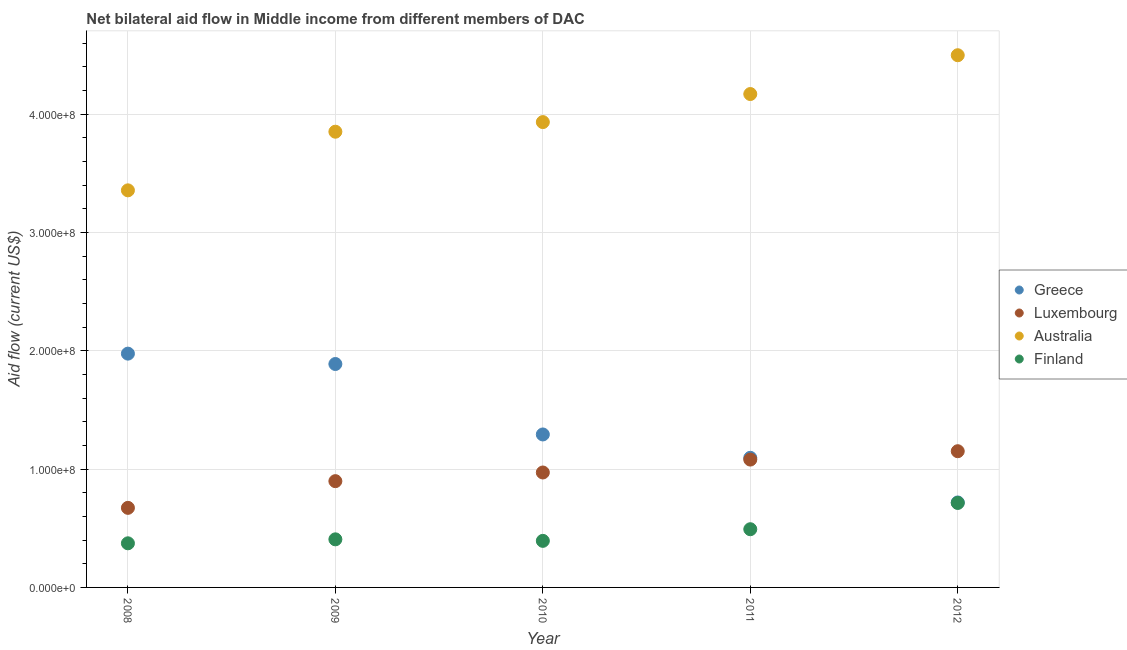What is the amount of aid given by greece in 2010?
Your response must be concise. 1.29e+08. Across all years, what is the maximum amount of aid given by luxembourg?
Your response must be concise. 1.15e+08. Across all years, what is the minimum amount of aid given by australia?
Provide a succinct answer. 3.36e+08. What is the total amount of aid given by australia in the graph?
Your answer should be compact. 1.98e+09. What is the difference between the amount of aid given by australia in 2008 and that in 2009?
Give a very brief answer. -4.96e+07. What is the difference between the amount of aid given by greece in 2012 and the amount of aid given by luxembourg in 2009?
Keep it short and to the point. -1.80e+07. What is the average amount of aid given by australia per year?
Provide a short and direct response. 3.96e+08. In the year 2012, what is the difference between the amount of aid given by luxembourg and amount of aid given by greece?
Provide a short and direct response. 4.33e+07. What is the ratio of the amount of aid given by australia in 2009 to that in 2011?
Ensure brevity in your answer.  0.92. What is the difference between the highest and the second highest amount of aid given by finland?
Your answer should be compact. 2.22e+07. What is the difference between the highest and the lowest amount of aid given by finland?
Keep it short and to the point. 3.41e+07. In how many years, is the amount of aid given by luxembourg greater than the average amount of aid given by luxembourg taken over all years?
Provide a succinct answer. 3. Is the amount of aid given by greece strictly greater than the amount of aid given by australia over the years?
Ensure brevity in your answer.  No. Is the amount of aid given by greece strictly less than the amount of aid given by luxembourg over the years?
Offer a very short reply. No. How many years are there in the graph?
Offer a terse response. 5. How many legend labels are there?
Keep it short and to the point. 4. What is the title of the graph?
Your answer should be compact. Net bilateral aid flow in Middle income from different members of DAC. What is the Aid flow (current US$) in Greece in 2008?
Provide a short and direct response. 1.98e+08. What is the Aid flow (current US$) in Luxembourg in 2008?
Offer a very short reply. 6.73e+07. What is the Aid flow (current US$) of Australia in 2008?
Keep it short and to the point. 3.36e+08. What is the Aid flow (current US$) of Finland in 2008?
Give a very brief answer. 3.73e+07. What is the Aid flow (current US$) of Greece in 2009?
Offer a terse response. 1.89e+08. What is the Aid flow (current US$) in Luxembourg in 2009?
Provide a short and direct response. 8.98e+07. What is the Aid flow (current US$) in Australia in 2009?
Your response must be concise. 3.85e+08. What is the Aid flow (current US$) of Finland in 2009?
Your answer should be compact. 4.06e+07. What is the Aid flow (current US$) of Greece in 2010?
Your answer should be very brief. 1.29e+08. What is the Aid flow (current US$) of Luxembourg in 2010?
Make the answer very short. 9.72e+07. What is the Aid flow (current US$) of Australia in 2010?
Your response must be concise. 3.93e+08. What is the Aid flow (current US$) in Finland in 2010?
Your answer should be very brief. 3.94e+07. What is the Aid flow (current US$) of Greece in 2011?
Provide a succinct answer. 1.10e+08. What is the Aid flow (current US$) in Luxembourg in 2011?
Provide a succinct answer. 1.08e+08. What is the Aid flow (current US$) in Australia in 2011?
Provide a short and direct response. 4.17e+08. What is the Aid flow (current US$) in Finland in 2011?
Provide a succinct answer. 4.92e+07. What is the Aid flow (current US$) of Greece in 2012?
Keep it short and to the point. 7.18e+07. What is the Aid flow (current US$) in Luxembourg in 2012?
Make the answer very short. 1.15e+08. What is the Aid flow (current US$) of Australia in 2012?
Your response must be concise. 4.50e+08. What is the Aid flow (current US$) in Finland in 2012?
Make the answer very short. 7.14e+07. Across all years, what is the maximum Aid flow (current US$) in Greece?
Your answer should be very brief. 1.98e+08. Across all years, what is the maximum Aid flow (current US$) of Luxembourg?
Keep it short and to the point. 1.15e+08. Across all years, what is the maximum Aid flow (current US$) in Australia?
Offer a terse response. 4.50e+08. Across all years, what is the maximum Aid flow (current US$) in Finland?
Provide a succinct answer. 7.14e+07. Across all years, what is the minimum Aid flow (current US$) in Greece?
Ensure brevity in your answer.  7.18e+07. Across all years, what is the minimum Aid flow (current US$) in Luxembourg?
Provide a succinct answer. 6.73e+07. Across all years, what is the minimum Aid flow (current US$) in Australia?
Make the answer very short. 3.36e+08. Across all years, what is the minimum Aid flow (current US$) of Finland?
Provide a short and direct response. 3.73e+07. What is the total Aid flow (current US$) of Greece in the graph?
Your answer should be compact. 6.97e+08. What is the total Aid flow (current US$) of Luxembourg in the graph?
Offer a very short reply. 4.77e+08. What is the total Aid flow (current US$) in Australia in the graph?
Offer a very short reply. 1.98e+09. What is the total Aid flow (current US$) of Finland in the graph?
Offer a very short reply. 2.38e+08. What is the difference between the Aid flow (current US$) of Greece in 2008 and that in 2009?
Offer a very short reply. 8.77e+06. What is the difference between the Aid flow (current US$) of Luxembourg in 2008 and that in 2009?
Provide a succinct answer. -2.26e+07. What is the difference between the Aid flow (current US$) of Australia in 2008 and that in 2009?
Keep it short and to the point. -4.96e+07. What is the difference between the Aid flow (current US$) in Finland in 2008 and that in 2009?
Your answer should be very brief. -3.36e+06. What is the difference between the Aid flow (current US$) in Greece in 2008 and that in 2010?
Ensure brevity in your answer.  6.83e+07. What is the difference between the Aid flow (current US$) of Luxembourg in 2008 and that in 2010?
Ensure brevity in your answer.  -2.99e+07. What is the difference between the Aid flow (current US$) in Australia in 2008 and that in 2010?
Ensure brevity in your answer.  -5.77e+07. What is the difference between the Aid flow (current US$) in Finland in 2008 and that in 2010?
Offer a very short reply. -2.07e+06. What is the difference between the Aid flow (current US$) of Greece in 2008 and that in 2011?
Offer a terse response. 8.81e+07. What is the difference between the Aid flow (current US$) of Luxembourg in 2008 and that in 2011?
Give a very brief answer. -4.08e+07. What is the difference between the Aid flow (current US$) in Australia in 2008 and that in 2011?
Offer a terse response. -8.14e+07. What is the difference between the Aid flow (current US$) of Finland in 2008 and that in 2011?
Provide a short and direct response. -1.19e+07. What is the difference between the Aid flow (current US$) in Greece in 2008 and that in 2012?
Ensure brevity in your answer.  1.26e+08. What is the difference between the Aid flow (current US$) in Luxembourg in 2008 and that in 2012?
Your response must be concise. -4.79e+07. What is the difference between the Aid flow (current US$) in Australia in 2008 and that in 2012?
Offer a terse response. -1.14e+08. What is the difference between the Aid flow (current US$) of Finland in 2008 and that in 2012?
Offer a very short reply. -3.41e+07. What is the difference between the Aid flow (current US$) of Greece in 2009 and that in 2010?
Provide a short and direct response. 5.96e+07. What is the difference between the Aid flow (current US$) in Luxembourg in 2009 and that in 2010?
Provide a succinct answer. -7.32e+06. What is the difference between the Aid flow (current US$) of Australia in 2009 and that in 2010?
Provide a succinct answer. -8.13e+06. What is the difference between the Aid flow (current US$) in Finland in 2009 and that in 2010?
Your answer should be compact. 1.29e+06. What is the difference between the Aid flow (current US$) in Greece in 2009 and that in 2011?
Your answer should be very brief. 7.93e+07. What is the difference between the Aid flow (current US$) of Luxembourg in 2009 and that in 2011?
Ensure brevity in your answer.  -1.82e+07. What is the difference between the Aid flow (current US$) of Australia in 2009 and that in 2011?
Offer a very short reply. -3.18e+07. What is the difference between the Aid flow (current US$) of Finland in 2009 and that in 2011?
Give a very brief answer. -8.55e+06. What is the difference between the Aid flow (current US$) of Greece in 2009 and that in 2012?
Offer a terse response. 1.17e+08. What is the difference between the Aid flow (current US$) in Luxembourg in 2009 and that in 2012?
Your answer should be compact. -2.53e+07. What is the difference between the Aid flow (current US$) in Australia in 2009 and that in 2012?
Your answer should be compact. -6.46e+07. What is the difference between the Aid flow (current US$) of Finland in 2009 and that in 2012?
Ensure brevity in your answer.  -3.08e+07. What is the difference between the Aid flow (current US$) in Greece in 2010 and that in 2011?
Offer a terse response. 1.98e+07. What is the difference between the Aid flow (current US$) of Luxembourg in 2010 and that in 2011?
Your answer should be compact. -1.09e+07. What is the difference between the Aid flow (current US$) of Australia in 2010 and that in 2011?
Offer a very short reply. -2.37e+07. What is the difference between the Aid flow (current US$) in Finland in 2010 and that in 2011?
Make the answer very short. -9.84e+06. What is the difference between the Aid flow (current US$) in Greece in 2010 and that in 2012?
Provide a short and direct response. 5.75e+07. What is the difference between the Aid flow (current US$) in Luxembourg in 2010 and that in 2012?
Make the answer very short. -1.80e+07. What is the difference between the Aid flow (current US$) of Australia in 2010 and that in 2012?
Your response must be concise. -5.65e+07. What is the difference between the Aid flow (current US$) of Finland in 2010 and that in 2012?
Offer a very short reply. -3.20e+07. What is the difference between the Aid flow (current US$) in Greece in 2011 and that in 2012?
Your answer should be compact. 3.77e+07. What is the difference between the Aid flow (current US$) in Luxembourg in 2011 and that in 2012?
Keep it short and to the point. -7.07e+06. What is the difference between the Aid flow (current US$) in Australia in 2011 and that in 2012?
Give a very brief answer. -3.28e+07. What is the difference between the Aid flow (current US$) in Finland in 2011 and that in 2012?
Give a very brief answer. -2.22e+07. What is the difference between the Aid flow (current US$) in Greece in 2008 and the Aid flow (current US$) in Luxembourg in 2009?
Ensure brevity in your answer.  1.08e+08. What is the difference between the Aid flow (current US$) in Greece in 2008 and the Aid flow (current US$) in Australia in 2009?
Provide a short and direct response. -1.88e+08. What is the difference between the Aid flow (current US$) in Greece in 2008 and the Aid flow (current US$) in Finland in 2009?
Provide a short and direct response. 1.57e+08. What is the difference between the Aid flow (current US$) of Luxembourg in 2008 and the Aid flow (current US$) of Australia in 2009?
Offer a very short reply. -3.18e+08. What is the difference between the Aid flow (current US$) in Luxembourg in 2008 and the Aid flow (current US$) in Finland in 2009?
Your response must be concise. 2.66e+07. What is the difference between the Aid flow (current US$) in Australia in 2008 and the Aid flow (current US$) in Finland in 2009?
Provide a short and direct response. 2.95e+08. What is the difference between the Aid flow (current US$) in Greece in 2008 and the Aid flow (current US$) in Luxembourg in 2010?
Provide a succinct answer. 1.00e+08. What is the difference between the Aid flow (current US$) of Greece in 2008 and the Aid flow (current US$) of Australia in 2010?
Offer a terse response. -1.96e+08. What is the difference between the Aid flow (current US$) in Greece in 2008 and the Aid flow (current US$) in Finland in 2010?
Offer a terse response. 1.58e+08. What is the difference between the Aid flow (current US$) of Luxembourg in 2008 and the Aid flow (current US$) of Australia in 2010?
Offer a very short reply. -3.26e+08. What is the difference between the Aid flow (current US$) in Luxembourg in 2008 and the Aid flow (current US$) in Finland in 2010?
Ensure brevity in your answer.  2.79e+07. What is the difference between the Aid flow (current US$) of Australia in 2008 and the Aid flow (current US$) of Finland in 2010?
Ensure brevity in your answer.  2.96e+08. What is the difference between the Aid flow (current US$) of Greece in 2008 and the Aid flow (current US$) of Luxembourg in 2011?
Make the answer very short. 8.96e+07. What is the difference between the Aid flow (current US$) in Greece in 2008 and the Aid flow (current US$) in Australia in 2011?
Offer a terse response. -2.19e+08. What is the difference between the Aid flow (current US$) of Greece in 2008 and the Aid flow (current US$) of Finland in 2011?
Keep it short and to the point. 1.48e+08. What is the difference between the Aid flow (current US$) of Luxembourg in 2008 and the Aid flow (current US$) of Australia in 2011?
Offer a very short reply. -3.50e+08. What is the difference between the Aid flow (current US$) in Luxembourg in 2008 and the Aid flow (current US$) in Finland in 2011?
Keep it short and to the point. 1.81e+07. What is the difference between the Aid flow (current US$) of Australia in 2008 and the Aid flow (current US$) of Finland in 2011?
Make the answer very short. 2.86e+08. What is the difference between the Aid flow (current US$) of Greece in 2008 and the Aid flow (current US$) of Luxembourg in 2012?
Provide a short and direct response. 8.25e+07. What is the difference between the Aid flow (current US$) of Greece in 2008 and the Aid flow (current US$) of Australia in 2012?
Provide a short and direct response. -2.52e+08. What is the difference between the Aid flow (current US$) in Greece in 2008 and the Aid flow (current US$) in Finland in 2012?
Make the answer very short. 1.26e+08. What is the difference between the Aid flow (current US$) in Luxembourg in 2008 and the Aid flow (current US$) in Australia in 2012?
Your response must be concise. -3.83e+08. What is the difference between the Aid flow (current US$) in Luxembourg in 2008 and the Aid flow (current US$) in Finland in 2012?
Offer a terse response. -4.15e+06. What is the difference between the Aid flow (current US$) of Australia in 2008 and the Aid flow (current US$) of Finland in 2012?
Give a very brief answer. 2.64e+08. What is the difference between the Aid flow (current US$) of Greece in 2009 and the Aid flow (current US$) of Luxembourg in 2010?
Offer a terse response. 9.17e+07. What is the difference between the Aid flow (current US$) of Greece in 2009 and the Aid flow (current US$) of Australia in 2010?
Your answer should be very brief. -2.04e+08. What is the difference between the Aid flow (current US$) in Greece in 2009 and the Aid flow (current US$) in Finland in 2010?
Your answer should be very brief. 1.49e+08. What is the difference between the Aid flow (current US$) in Luxembourg in 2009 and the Aid flow (current US$) in Australia in 2010?
Your answer should be very brief. -3.04e+08. What is the difference between the Aid flow (current US$) of Luxembourg in 2009 and the Aid flow (current US$) of Finland in 2010?
Offer a terse response. 5.05e+07. What is the difference between the Aid flow (current US$) in Australia in 2009 and the Aid flow (current US$) in Finland in 2010?
Your response must be concise. 3.46e+08. What is the difference between the Aid flow (current US$) of Greece in 2009 and the Aid flow (current US$) of Luxembourg in 2011?
Provide a succinct answer. 8.08e+07. What is the difference between the Aid flow (current US$) of Greece in 2009 and the Aid flow (current US$) of Australia in 2011?
Ensure brevity in your answer.  -2.28e+08. What is the difference between the Aid flow (current US$) in Greece in 2009 and the Aid flow (current US$) in Finland in 2011?
Ensure brevity in your answer.  1.40e+08. What is the difference between the Aid flow (current US$) in Luxembourg in 2009 and the Aid flow (current US$) in Australia in 2011?
Offer a very short reply. -3.27e+08. What is the difference between the Aid flow (current US$) of Luxembourg in 2009 and the Aid flow (current US$) of Finland in 2011?
Offer a terse response. 4.06e+07. What is the difference between the Aid flow (current US$) of Australia in 2009 and the Aid flow (current US$) of Finland in 2011?
Offer a terse response. 3.36e+08. What is the difference between the Aid flow (current US$) in Greece in 2009 and the Aid flow (current US$) in Luxembourg in 2012?
Your answer should be very brief. 7.37e+07. What is the difference between the Aid flow (current US$) of Greece in 2009 and the Aid flow (current US$) of Australia in 2012?
Ensure brevity in your answer.  -2.61e+08. What is the difference between the Aid flow (current US$) of Greece in 2009 and the Aid flow (current US$) of Finland in 2012?
Give a very brief answer. 1.17e+08. What is the difference between the Aid flow (current US$) in Luxembourg in 2009 and the Aid flow (current US$) in Australia in 2012?
Offer a very short reply. -3.60e+08. What is the difference between the Aid flow (current US$) in Luxembourg in 2009 and the Aid flow (current US$) in Finland in 2012?
Offer a terse response. 1.84e+07. What is the difference between the Aid flow (current US$) of Australia in 2009 and the Aid flow (current US$) of Finland in 2012?
Offer a terse response. 3.14e+08. What is the difference between the Aid flow (current US$) of Greece in 2010 and the Aid flow (current US$) of Luxembourg in 2011?
Offer a very short reply. 2.12e+07. What is the difference between the Aid flow (current US$) of Greece in 2010 and the Aid flow (current US$) of Australia in 2011?
Provide a short and direct response. -2.88e+08. What is the difference between the Aid flow (current US$) in Greece in 2010 and the Aid flow (current US$) in Finland in 2011?
Make the answer very short. 8.01e+07. What is the difference between the Aid flow (current US$) in Luxembourg in 2010 and the Aid flow (current US$) in Australia in 2011?
Offer a very short reply. -3.20e+08. What is the difference between the Aid flow (current US$) in Luxembourg in 2010 and the Aid flow (current US$) in Finland in 2011?
Offer a terse response. 4.80e+07. What is the difference between the Aid flow (current US$) of Australia in 2010 and the Aid flow (current US$) of Finland in 2011?
Your answer should be compact. 3.44e+08. What is the difference between the Aid flow (current US$) in Greece in 2010 and the Aid flow (current US$) in Luxembourg in 2012?
Your response must be concise. 1.42e+07. What is the difference between the Aid flow (current US$) of Greece in 2010 and the Aid flow (current US$) of Australia in 2012?
Offer a very short reply. -3.21e+08. What is the difference between the Aid flow (current US$) in Greece in 2010 and the Aid flow (current US$) in Finland in 2012?
Make the answer very short. 5.79e+07. What is the difference between the Aid flow (current US$) in Luxembourg in 2010 and the Aid flow (current US$) in Australia in 2012?
Offer a very short reply. -3.53e+08. What is the difference between the Aid flow (current US$) of Luxembourg in 2010 and the Aid flow (current US$) of Finland in 2012?
Your answer should be very brief. 2.57e+07. What is the difference between the Aid flow (current US$) in Australia in 2010 and the Aid flow (current US$) in Finland in 2012?
Keep it short and to the point. 3.22e+08. What is the difference between the Aid flow (current US$) of Greece in 2011 and the Aid flow (current US$) of Luxembourg in 2012?
Your answer should be very brief. -5.59e+06. What is the difference between the Aid flow (current US$) of Greece in 2011 and the Aid flow (current US$) of Australia in 2012?
Your answer should be very brief. -3.40e+08. What is the difference between the Aid flow (current US$) of Greece in 2011 and the Aid flow (current US$) of Finland in 2012?
Provide a succinct answer. 3.81e+07. What is the difference between the Aid flow (current US$) of Luxembourg in 2011 and the Aid flow (current US$) of Australia in 2012?
Your response must be concise. -3.42e+08. What is the difference between the Aid flow (current US$) of Luxembourg in 2011 and the Aid flow (current US$) of Finland in 2012?
Offer a very short reply. 3.67e+07. What is the difference between the Aid flow (current US$) in Australia in 2011 and the Aid flow (current US$) in Finland in 2012?
Make the answer very short. 3.46e+08. What is the average Aid flow (current US$) in Greece per year?
Provide a succinct answer. 1.39e+08. What is the average Aid flow (current US$) of Luxembourg per year?
Offer a terse response. 9.55e+07. What is the average Aid flow (current US$) of Australia per year?
Give a very brief answer. 3.96e+08. What is the average Aid flow (current US$) in Finland per year?
Provide a short and direct response. 4.76e+07. In the year 2008, what is the difference between the Aid flow (current US$) of Greece and Aid flow (current US$) of Luxembourg?
Offer a terse response. 1.30e+08. In the year 2008, what is the difference between the Aid flow (current US$) in Greece and Aid flow (current US$) in Australia?
Ensure brevity in your answer.  -1.38e+08. In the year 2008, what is the difference between the Aid flow (current US$) in Greece and Aid flow (current US$) in Finland?
Your answer should be compact. 1.60e+08. In the year 2008, what is the difference between the Aid flow (current US$) in Luxembourg and Aid flow (current US$) in Australia?
Keep it short and to the point. -2.68e+08. In the year 2008, what is the difference between the Aid flow (current US$) in Luxembourg and Aid flow (current US$) in Finland?
Offer a very short reply. 3.00e+07. In the year 2008, what is the difference between the Aid flow (current US$) of Australia and Aid flow (current US$) of Finland?
Give a very brief answer. 2.98e+08. In the year 2009, what is the difference between the Aid flow (current US$) of Greece and Aid flow (current US$) of Luxembourg?
Your answer should be compact. 9.90e+07. In the year 2009, what is the difference between the Aid flow (current US$) of Greece and Aid flow (current US$) of Australia?
Make the answer very short. -1.96e+08. In the year 2009, what is the difference between the Aid flow (current US$) in Greece and Aid flow (current US$) in Finland?
Your response must be concise. 1.48e+08. In the year 2009, what is the difference between the Aid flow (current US$) of Luxembourg and Aid flow (current US$) of Australia?
Provide a succinct answer. -2.95e+08. In the year 2009, what is the difference between the Aid flow (current US$) in Luxembourg and Aid flow (current US$) in Finland?
Keep it short and to the point. 4.92e+07. In the year 2009, what is the difference between the Aid flow (current US$) of Australia and Aid flow (current US$) of Finland?
Keep it short and to the point. 3.45e+08. In the year 2010, what is the difference between the Aid flow (current US$) in Greece and Aid flow (current US$) in Luxembourg?
Your answer should be very brief. 3.22e+07. In the year 2010, what is the difference between the Aid flow (current US$) in Greece and Aid flow (current US$) in Australia?
Offer a very short reply. -2.64e+08. In the year 2010, what is the difference between the Aid flow (current US$) in Greece and Aid flow (current US$) in Finland?
Ensure brevity in your answer.  8.99e+07. In the year 2010, what is the difference between the Aid flow (current US$) of Luxembourg and Aid flow (current US$) of Australia?
Make the answer very short. -2.96e+08. In the year 2010, what is the difference between the Aid flow (current US$) of Luxembourg and Aid flow (current US$) of Finland?
Your answer should be compact. 5.78e+07. In the year 2010, what is the difference between the Aid flow (current US$) in Australia and Aid flow (current US$) in Finland?
Make the answer very short. 3.54e+08. In the year 2011, what is the difference between the Aid flow (current US$) in Greece and Aid flow (current US$) in Luxembourg?
Offer a terse response. 1.48e+06. In the year 2011, what is the difference between the Aid flow (current US$) of Greece and Aid flow (current US$) of Australia?
Your response must be concise. -3.08e+08. In the year 2011, what is the difference between the Aid flow (current US$) in Greece and Aid flow (current US$) in Finland?
Give a very brief answer. 6.04e+07. In the year 2011, what is the difference between the Aid flow (current US$) of Luxembourg and Aid flow (current US$) of Australia?
Give a very brief answer. -3.09e+08. In the year 2011, what is the difference between the Aid flow (current US$) in Luxembourg and Aid flow (current US$) in Finland?
Provide a short and direct response. 5.89e+07. In the year 2011, what is the difference between the Aid flow (current US$) of Australia and Aid flow (current US$) of Finland?
Make the answer very short. 3.68e+08. In the year 2012, what is the difference between the Aid flow (current US$) of Greece and Aid flow (current US$) of Luxembourg?
Your answer should be compact. -4.33e+07. In the year 2012, what is the difference between the Aid flow (current US$) of Greece and Aid flow (current US$) of Australia?
Your answer should be compact. -3.78e+08. In the year 2012, what is the difference between the Aid flow (current US$) of Luxembourg and Aid flow (current US$) of Australia?
Keep it short and to the point. -3.35e+08. In the year 2012, what is the difference between the Aid flow (current US$) in Luxembourg and Aid flow (current US$) in Finland?
Make the answer very short. 4.37e+07. In the year 2012, what is the difference between the Aid flow (current US$) of Australia and Aid flow (current US$) of Finland?
Ensure brevity in your answer.  3.78e+08. What is the ratio of the Aid flow (current US$) of Greece in 2008 to that in 2009?
Keep it short and to the point. 1.05. What is the ratio of the Aid flow (current US$) in Luxembourg in 2008 to that in 2009?
Ensure brevity in your answer.  0.75. What is the ratio of the Aid flow (current US$) in Australia in 2008 to that in 2009?
Give a very brief answer. 0.87. What is the ratio of the Aid flow (current US$) of Finland in 2008 to that in 2009?
Offer a very short reply. 0.92. What is the ratio of the Aid flow (current US$) of Greece in 2008 to that in 2010?
Your response must be concise. 1.53. What is the ratio of the Aid flow (current US$) of Luxembourg in 2008 to that in 2010?
Your answer should be compact. 0.69. What is the ratio of the Aid flow (current US$) in Australia in 2008 to that in 2010?
Make the answer very short. 0.85. What is the ratio of the Aid flow (current US$) in Greece in 2008 to that in 2011?
Provide a succinct answer. 1.8. What is the ratio of the Aid flow (current US$) of Luxembourg in 2008 to that in 2011?
Make the answer very short. 0.62. What is the ratio of the Aid flow (current US$) of Australia in 2008 to that in 2011?
Provide a short and direct response. 0.8. What is the ratio of the Aid flow (current US$) of Finland in 2008 to that in 2011?
Give a very brief answer. 0.76. What is the ratio of the Aid flow (current US$) of Greece in 2008 to that in 2012?
Make the answer very short. 2.75. What is the ratio of the Aid flow (current US$) in Luxembourg in 2008 to that in 2012?
Provide a succinct answer. 0.58. What is the ratio of the Aid flow (current US$) of Australia in 2008 to that in 2012?
Provide a succinct answer. 0.75. What is the ratio of the Aid flow (current US$) in Finland in 2008 to that in 2012?
Ensure brevity in your answer.  0.52. What is the ratio of the Aid flow (current US$) of Greece in 2009 to that in 2010?
Make the answer very short. 1.46. What is the ratio of the Aid flow (current US$) in Luxembourg in 2009 to that in 2010?
Your answer should be very brief. 0.92. What is the ratio of the Aid flow (current US$) of Australia in 2009 to that in 2010?
Offer a very short reply. 0.98. What is the ratio of the Aid flow (current US$) of Finland in 2009 to that in 2010?
Ensure brevity in your answer.  1.03. What is the ratio of the Aid flow (current US$) in Greece in 2009 to that in 2011?
Ensure brevity in your answer.  1.72. What is the ratio of the Aid flow (current US$) in Luxembourg in 2009 to that in 2011?
Provide a short and direct response. 0.83. What is the ratio of the Aid flow (current US$) in Australia in 2009 to that in 2011?
Your answer should be compact. 0.92. What is the ratio of the Aid flow (current US$) of Finland in 2009 to that in 2011?
Provide a short and direct response. 0.83. What is the ratio of the Aid flow (current US$) of Greece in 2009 to that in 2012?
Your answer should be very brief. 2.63. What is the ratio of the Aid flow (current US$) of Luxembourg in 2009 to that in 2012?
Your response must be concise. 0.78. What is the ratio of the Aid flow (current US$) in Australia in 2009 to that in 2012?
Make the answer very short. 0.86. What is the ratio of the Aid flow (current US$) in Finland in 2009 to that in 2012?
Provide a short and direct response. 0.57. What is the ratio of the Aid flow (current US$) of Greece in 2010 to that in 2011?
Provide a short and direct response. 1.18. What is the ratio of the Aid flow (current US$) in Luxembourg in 2010 to that in 2011?
Offer a terse response. 0.9. What is the ratio of the Aid flow (current US$) in Australia in 2010 to that in 2011?
Offer a terse response. 0.94. What is the ratio of the Aid flow (current US$) in Greece in 2010 to that in 2012?
Offer a terse response. 1.8. What is the ratio of the Aid flow (current US$) in Luxembourg in 2010 to that in 2012?
Keep it short and to the point. 0.84. What is the ratio of the Aid flow (current US$) of Australia in 2010 to that in 2012?
Offer a very short reply. 0.87. What is the ratio of the Aid flow (current US$) in Finland in 2010 to that in 2012?
Provide a succinct answer. 0.55. What is the ratio of the Aid flow (current US$) in Greece in 2011 to that in 2012?
Make the answer very short. 1.53. What is the ratio of the Aid flow (current US$) of Luxembourg in 2011 to that in 2012?
Give a very brief answer. 0.94. What is the ratio of the Aid flow (current US$) in Australia in 2011 to that in 2012?
Provide a short and direct response. 0.93. What is the ratio of the Aid flow (current US$) of Finland in 2011 to that in 2012?
Make the answer very short. 0.69. What is the difference between the highest and the second highest Aid flow (current US$) of Greece?
Your answer should be very brief. 8.77e+06. What is the difference between the highest and the second highest Aid flow (current US$) of Luxembourg?
Your answer should be compact. 7.07e+06. What is the difference between the highest and the second highest Aid flow (current US$) in Australia?
Give a very brief answer. 3.28e+07. What is the difference between the highest and the second highest Aid flow (current US$) of Finland?
Your answer should be compact. 2.22e+07. What is the difference between the highest and the lowest Aid flow (current US$) in Greece?
Provide a short and direct response. 1.26e+08. What is the difference between the highest and the lowest Aid flow (current US$) in Luxembourg?
Offer a terse response. 4.79e+07. What is the difference between the highest and the lowest Aid flow (current US$) of Australia?
Provide a succinct answer. 1.14e+08. What is the difference between the highest and the lowest Aid flow (current US$) in Finland?
Provide a succinct answer. 3.41e+07. 